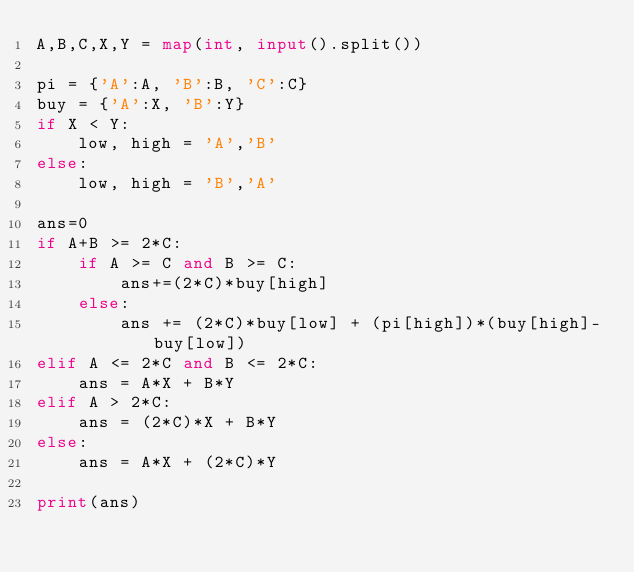<code> <loc_0><loc_0><loc_500><loc_500><_Python_>A,B,C,X,Y = map(int, input().split())

pi = {'A':A, 'B':B, 'C':C}
buy = {'A':X, 'B':Y}
if X < Y:
	low, high = 'A','B'
else:
	low, high = 'B','A'

ans=0
if A+B >= 2*C:
	if A >= C and B >= C:
		ans+=(2*C)*buy[high]
	else:
		ans += (2*C)*buy[low] + (pi[high])*(buy[high]-buy[low])
elif A <= 2*C and B <= 2*C:
	ans = A*X + B*Y
elif A > 2*C:
	ans = (2*C)*X + B*Y
else:
	ans = A*X + (2*C)*Y

print(ans)</code> 